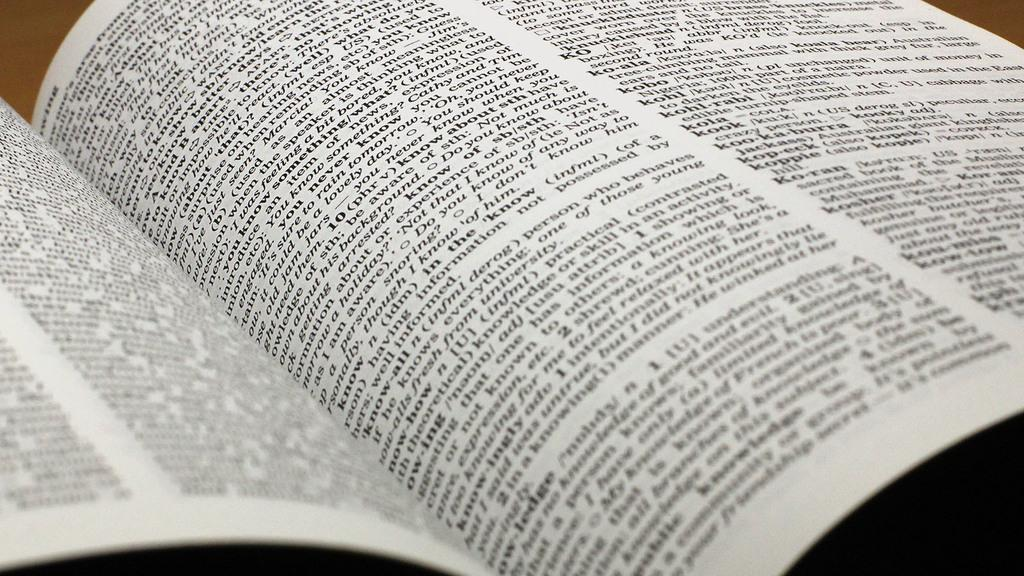<image>
Create a compact narrative representing the image presented. A dictionary page includes the words kopeck and koppie. 